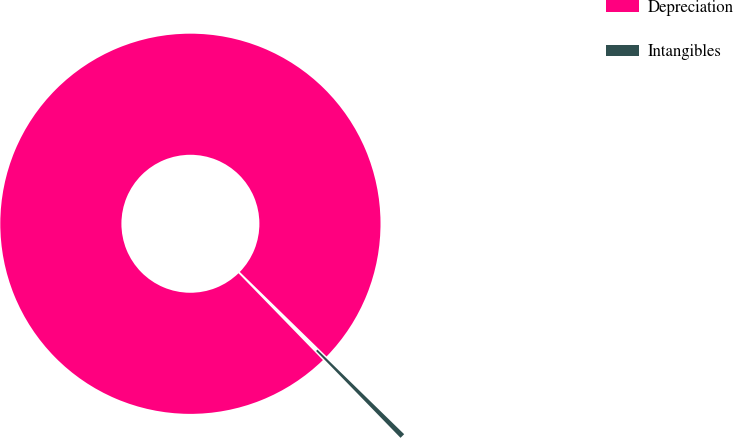Convert chart to OTSL. <chart><loc_0><loc_0><loc_500><loc_500><pie_chart><fcel>Depreciation<fcel>Intangibles<nl><fcel>99.57%<fcel>0.43%<nl></chart> 